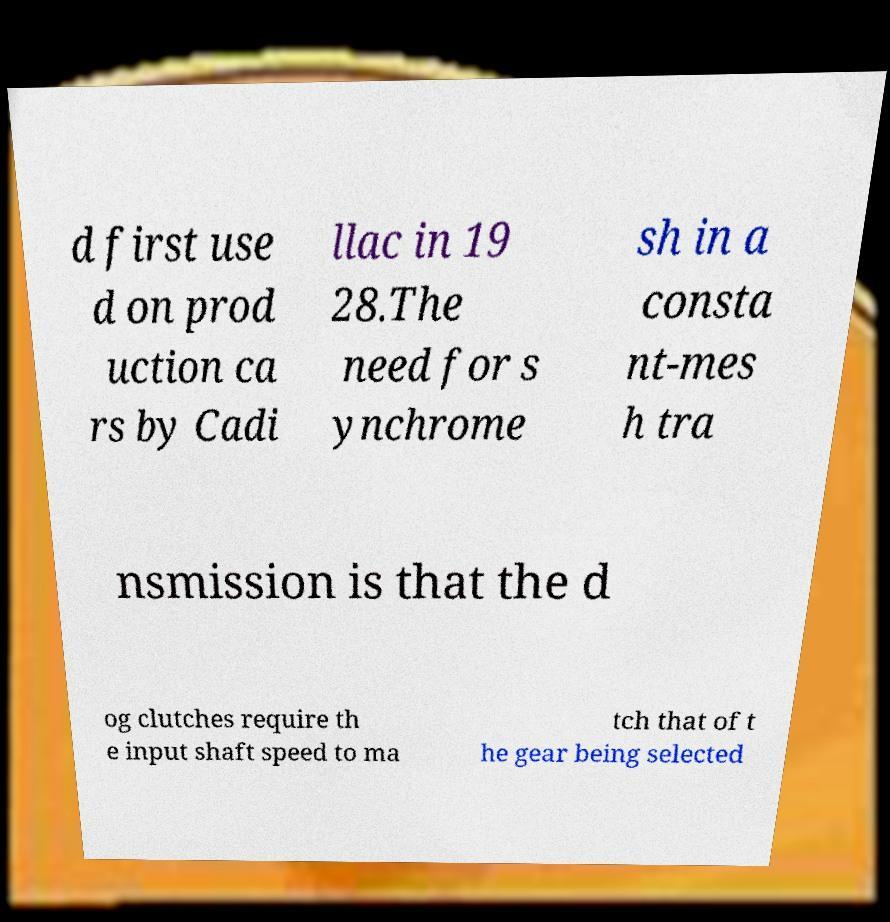Can you read and provide the text displayed in the image?This photo seems to have some interesting text. Can you extract and type it out for me? d first use d on prod uction ca rs by Cadi llac in 19 28.The need for s ynchrome sh in a consta nt-mes h tra nsmission is that the d og clutches require th e input shaft speed to ma tch that of t he gear being selected 